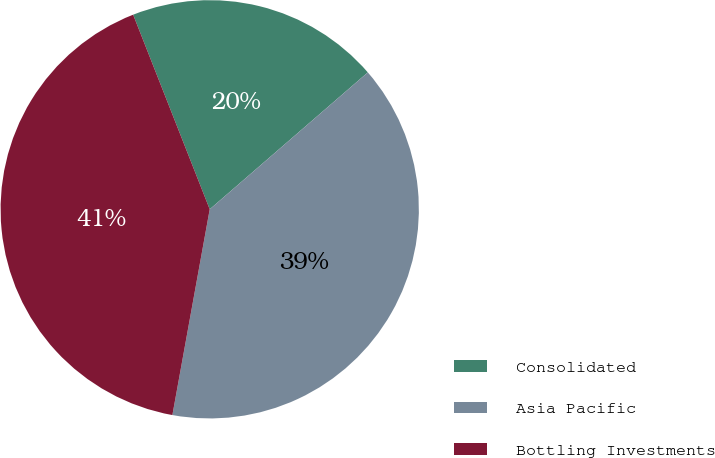<chart> <loc_0><loc_0><loc_500><loc_500><pie_chart><fcel>Consolidated<fcel>Asia Pacific<fcel>Bottling Investments<nl><fcel>19.61%<fcel>39.22%<fcel>41.18%<nl></chart> 